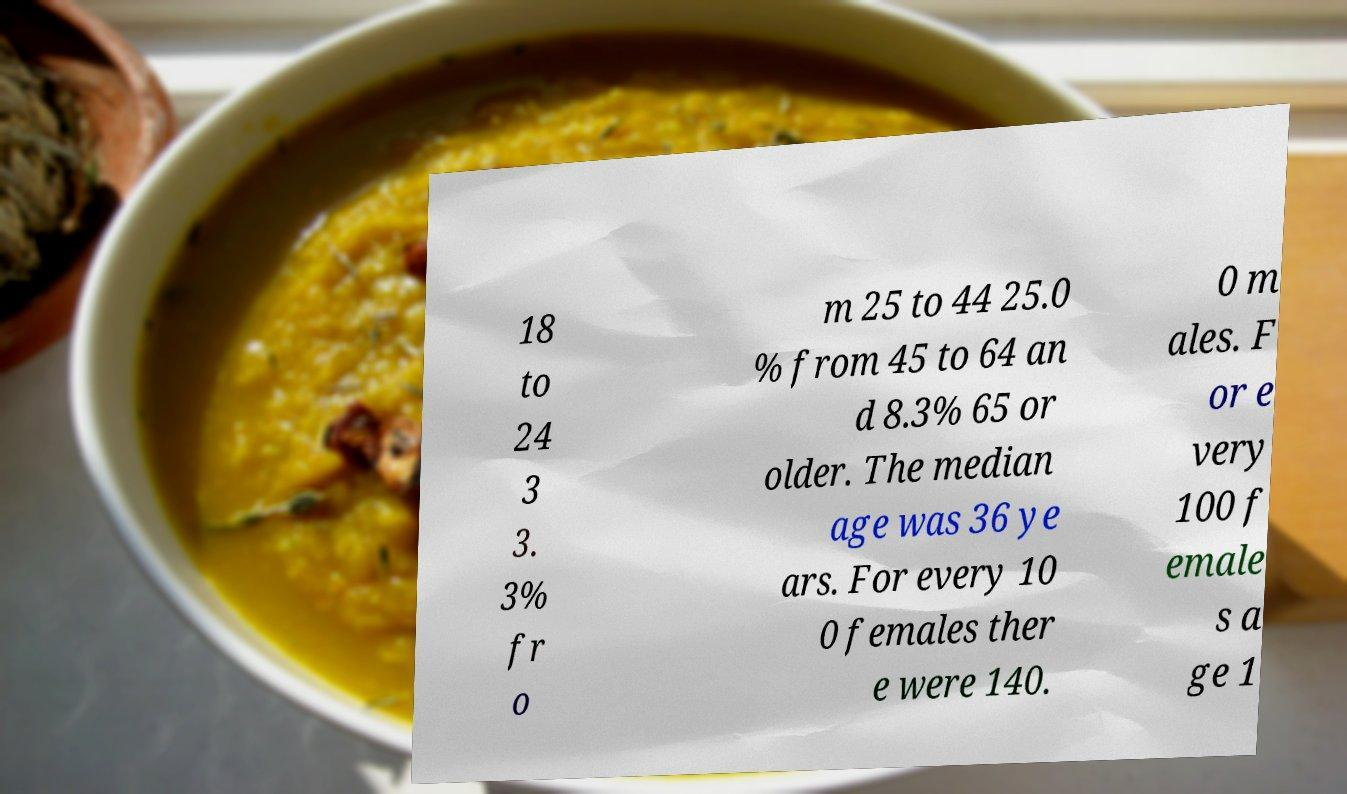Could you assist in decoding the text presented in this image and type it out clearly? 18 to 24 3 3. 3% fr o m 25 to 44 25.0 % from 45 to 64 an d 8.3% 65 or older. The median age was 36 ye ars. For every 10 0 females ther e were 140. 0 m ales. F or e very 100 f emale s a ge 1 